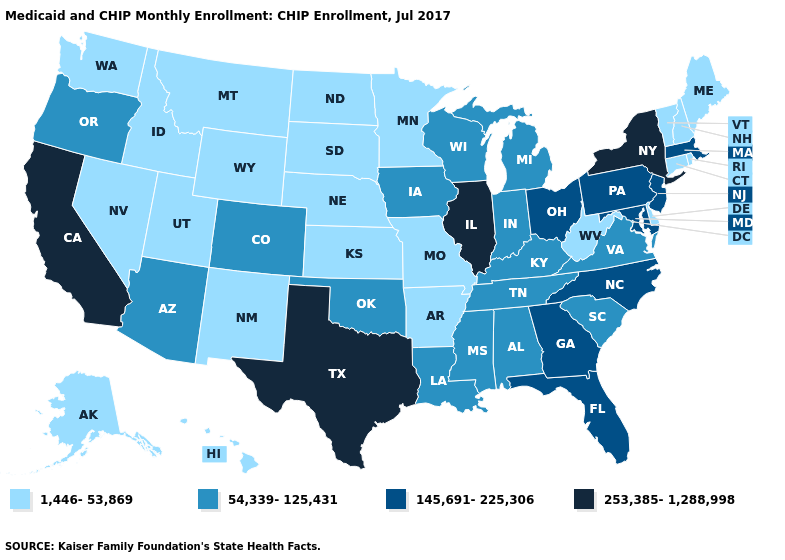Among the states that border Alabama , which have the lowest value?
Be succinct. Mississippi, Tennessee. Which states have the highest value in the USA?
Concise answer only. California, Illinois, New York, Texas. What is the highest value in states that border Oregon?
Quick response, please. 253,385-1,288,998. Name the states that have a value in the range 54,339-125,431?
Answer briefly. Alabama, Arizona, Colorado, Indiana, Iowa, Kentucky, Louisiana, Michigan, Mississippi, Oklahoma, Oregon, South Carolina, Tennessee, Virginia, Wisconsin. What is the highest value in states that border Rhode Island?
Quick response, please. 145,691-225,306. Which states have the lowest value in the USA?
Be succinct. Alaska, Arkansas, Connecticut, Delaware, Hawaii, Idaho, Kansas, Maine, Minnesota, Missouri, Montana, Nebraska, Nevada, New Hampshire, New Mexico, North Dakota, Rhode Island, South Dakota, Utah, Vermont, Washington, West Virginia, Wyoming. Name the states that have a value in the range 1,446-53,869?
Short answer required. Alaska, Arkansas, Connecticut, Delaware, Hawaii, Idaho, Kansas, Maine, Minnesota, Missouri, Montana, Nebraska, Nevada, New Hampshire, New Mexico, North Dakota, Rhode Island, South Dakota, Utah, Vermont, Washington, West Virginia, Wyoming. Name the states that have a value in the range 253,385-1,288,998?
Concise answer only. California, Illinois, New York, Texas. Name the states that have a value in the range 145,691-225,306?
Give a very brief answer. Florida, Georgia, Maryland, Massachusetts, New Jersey, North Carolina, Ohio, Pennsylvania. Which states hav the highest value in the South?
Be succinct. Texas. Among the states that border Georgia , which have the highest value?
Give a very brief answer. Florida, North Carolina. What is the value of Nevada?
Answer briefly. 1,446-53,869. Name the states that have a value in the range 145,691-225,306?
Quick response, please. Florida, Georgia, Maryland, Massachusetts, New Jersey, North Carolina, Ohio, Pennsylvania. Does Delaware have the highest value in the South?
Short answer required. No. Name the states that have a value in the range 253,385-1,288,998?
Quick response, please. California, Illinois, New York, Texas. 